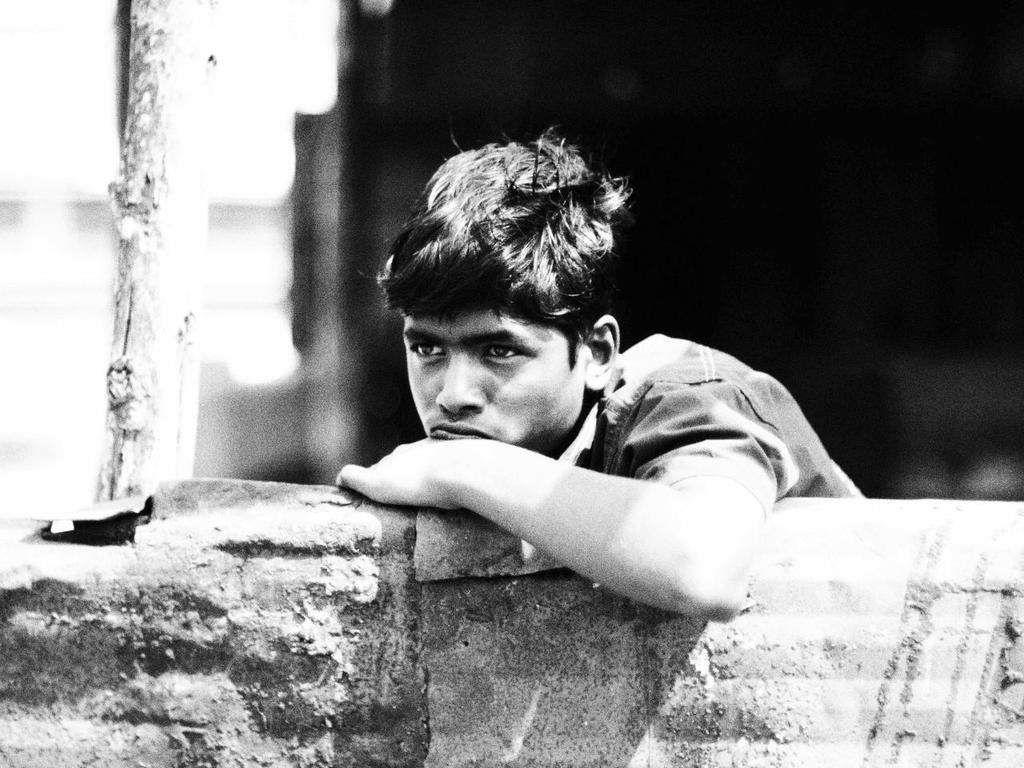How would you summarize this image in a sentence or two? In this image there is a boy standing. In front of him there is a wall. He is leaning on the wall. Beside him there is a stick. The background is blurry. 